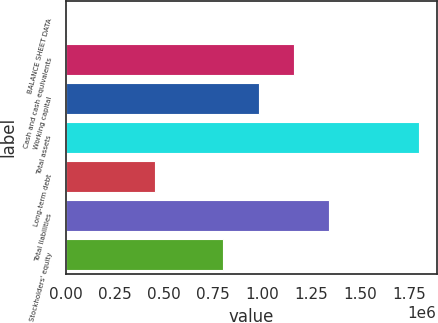Convert chart to OTSL. <chart><loc_0><loc_0><loc_500><loc_500><bar_chart><fcel>BALANCE SHEET DATA<fcel>Cash and cash equivalents<fcel>Working capital<fcel>Total assets<fcel>Long-term debt<fcel>Total liabilities<fcel>Stockholders' equity<nl><fcel>2014<fcel>1.16133e+06<fcel>981568<fcel>1.79963e+06<fcel>454031<fcel>1.34109e+06<fcel>801806<nl></chart> 